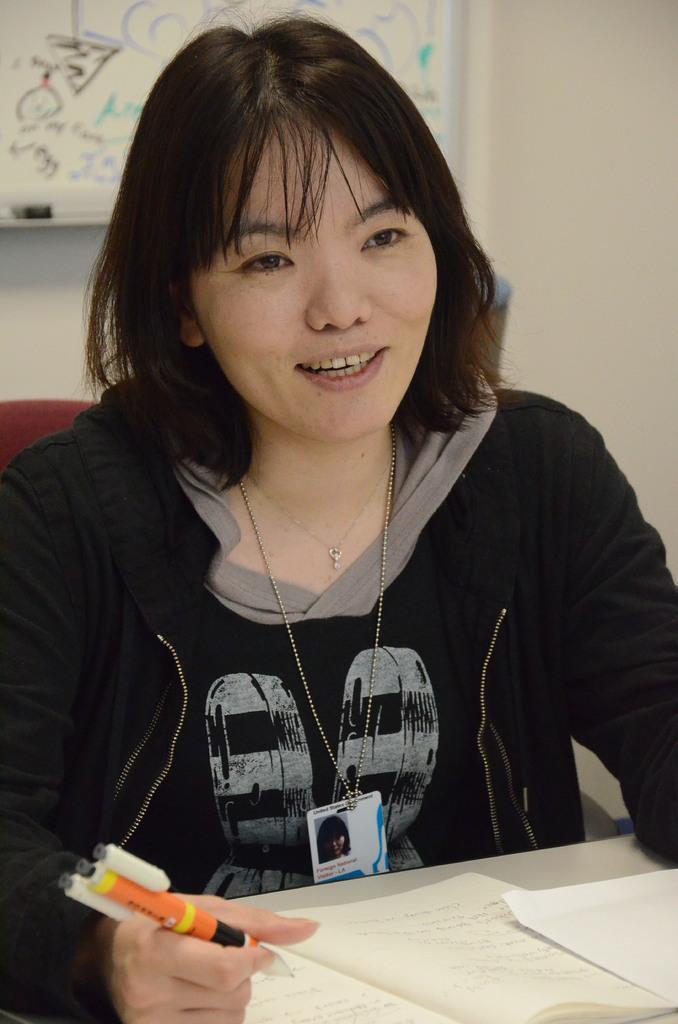Can you describe this image briefly? At the bottom of the image there is a table with a book and a paper. Behind the table there is a lady smiling and holding a pen in her hand. Behind her there is a wall with board. 